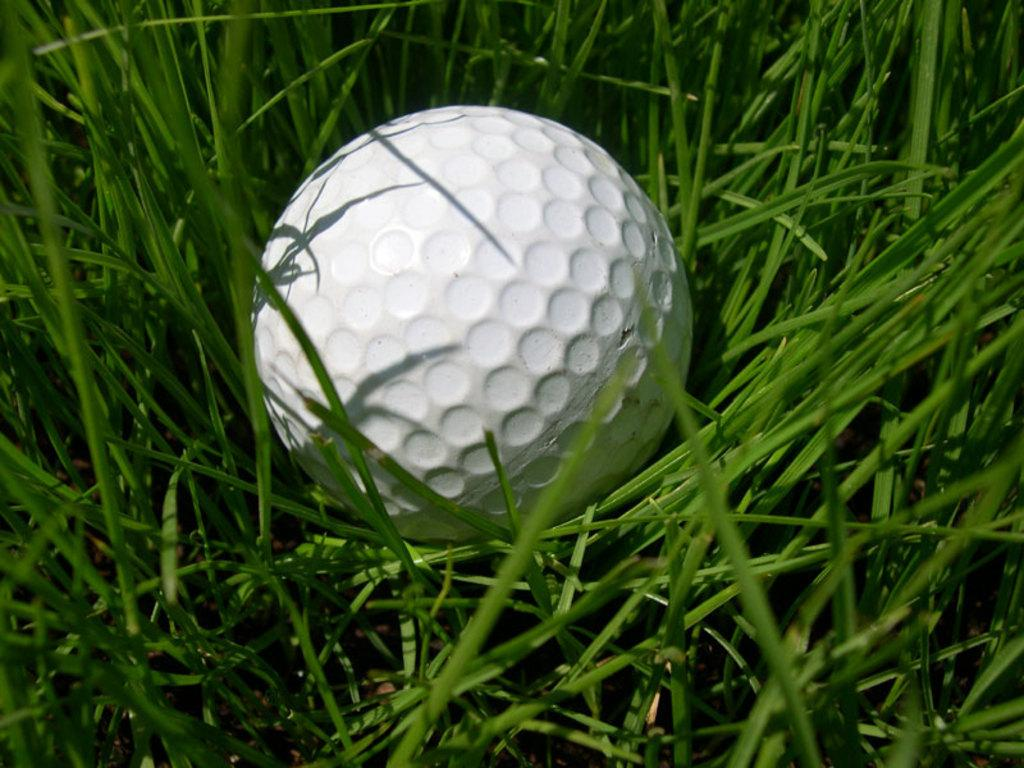What color is the ball in the image? The ball in the image is white. What type of surface is visible in the image? There is green grass in the image. What type of vest can be seen on the butter in the image? There is no vest or butter present in the image; it only features a white-colored ball and green grass. 